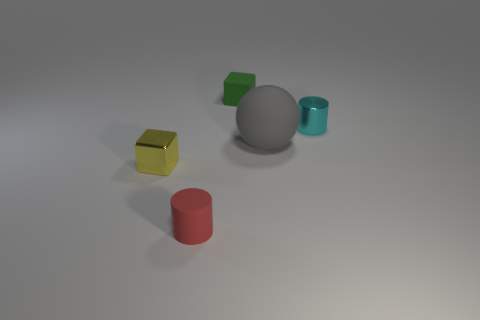Can you describe the lighting and shadows in the scene? The lighting in the scene appears to be coming from the upper right, which casts soft shadows towards the bottom left of the objects. This diffuse light creates a calm and even atmosphere. What does the shadowing tell us about the shape of the objects? The shadows provide cues about the three-dimensional form of the objects. For example, the shadows confirm the cylindrical shape of the red object, as we can see a rounded shadow. Similarly, the shadows of the cubes are square, aligning with their geometric shape. 